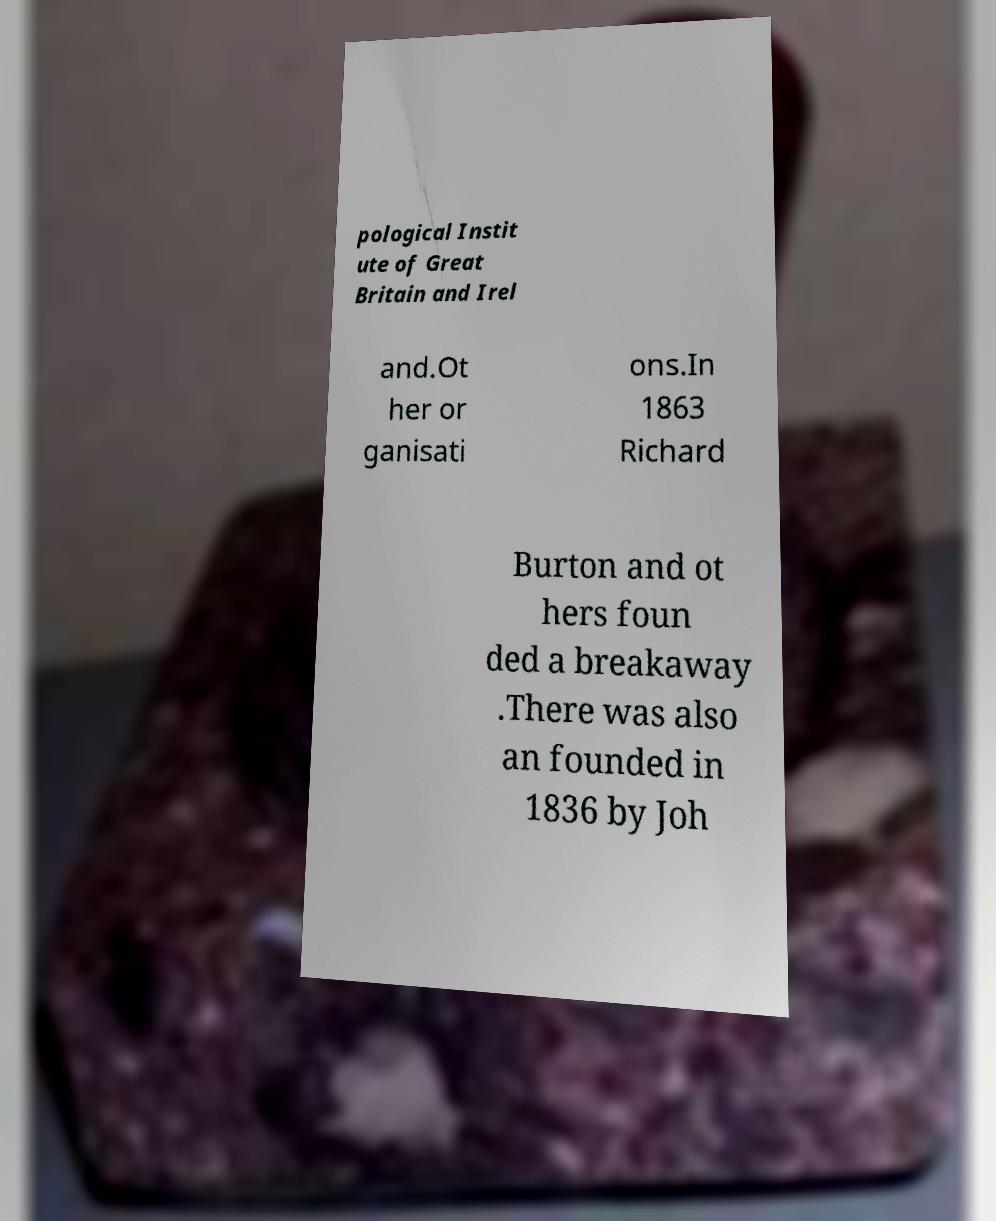I need the written content from this picture converted into text. Can you do that? pological Instit ute of Great Britain and Irel and.Ot her or ganisati ons.In 1863 Richard Burton and ot hers foun ded a breakaway .There was also an founded in 1836 by Joh 